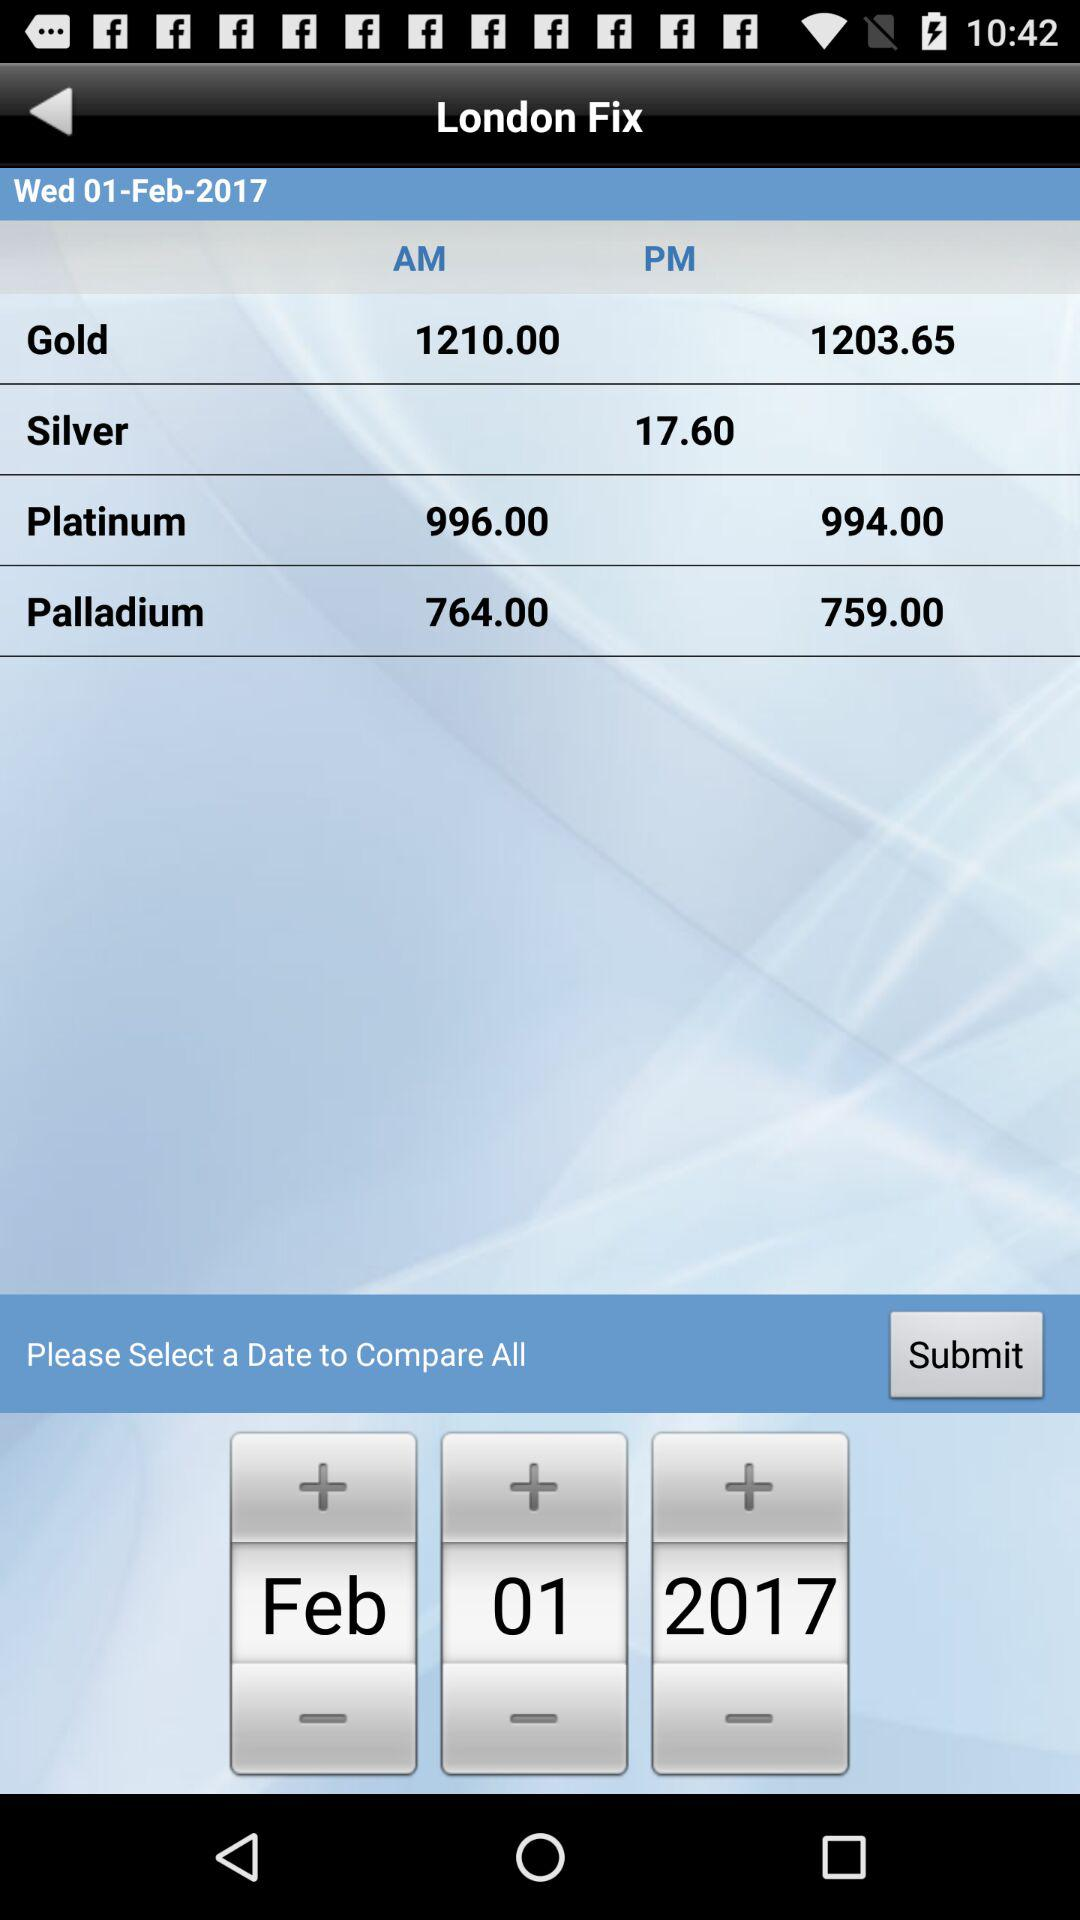What is the selected date? The selected date is February 1, 2017. 